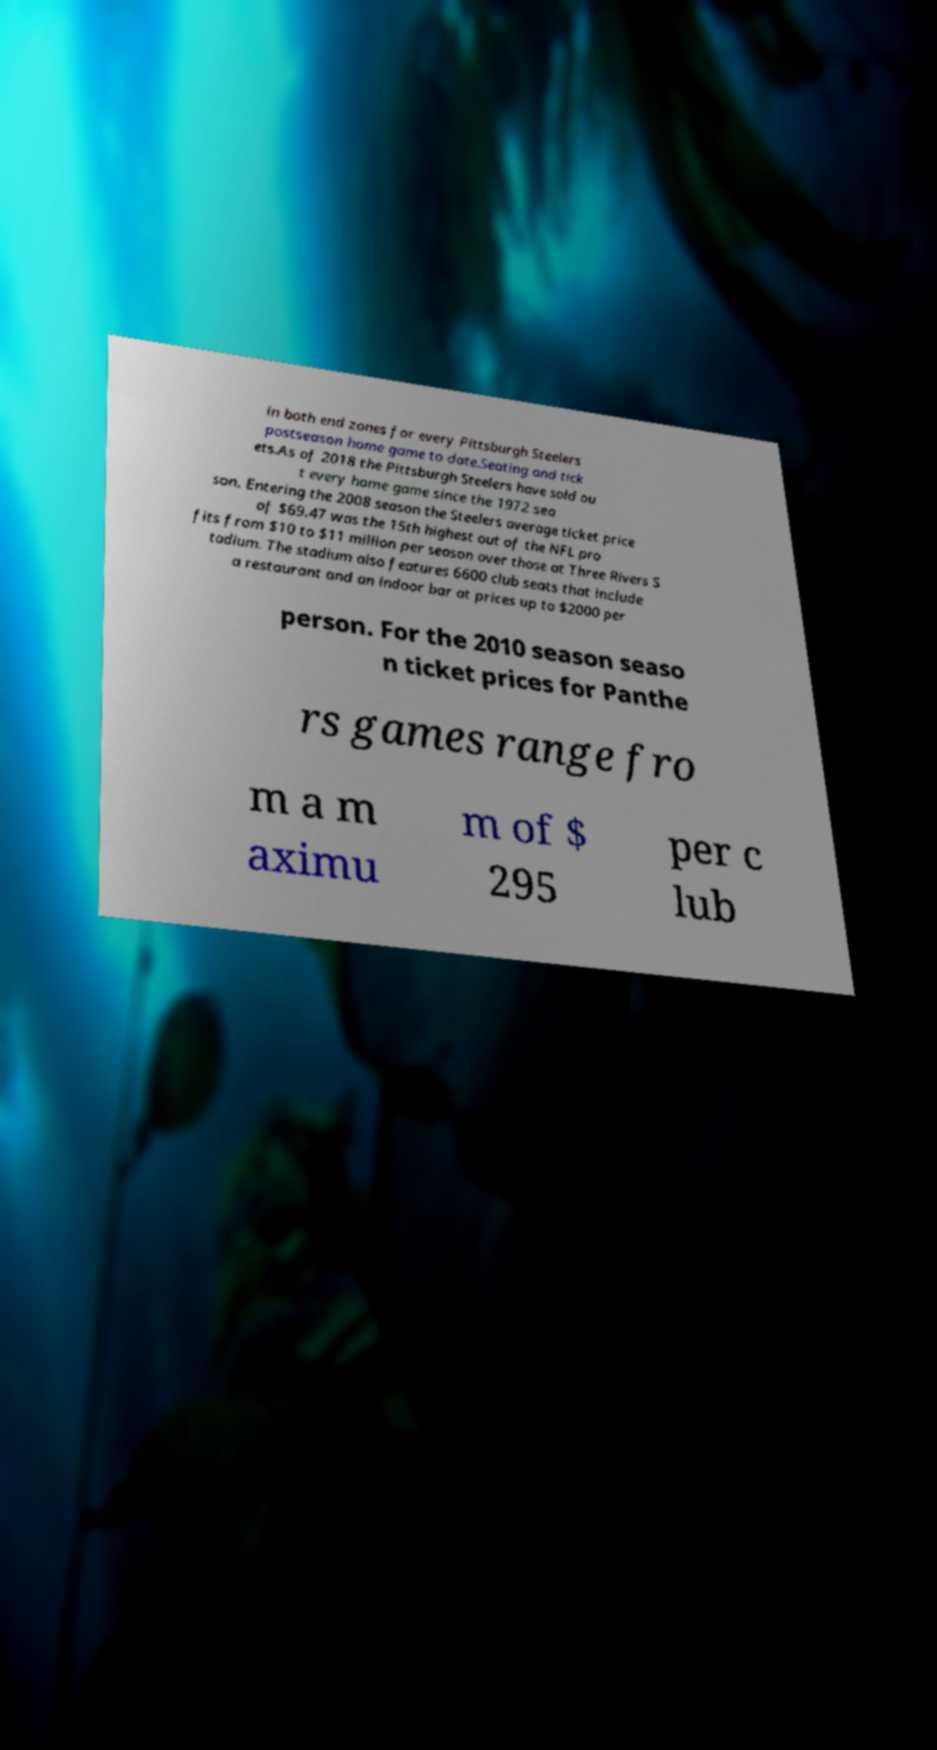Please identify and transcribe the text found in this image. in both end zones for every Pittsburgh Steelers postseason home game to date.Seating and tick ets.As of 2018 the Pittsburgh Steelers have sold ou t every home game since the 1972 sea son. Entering the 2008 season the Steelers average ticket price of $69.47 was the 15th highest out of the NFL pro fits from $10 to $11 million per season over those at Three Rivers S tadium. The stadium also features 6600 club seats that include a restaurant and an indoor bar at prices up to $2000 per person. For the 2010 season seaso n ticket prices for Panthe rs games range fro m a m aximu m of $ 295 per c lub 